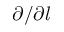Convert formula to latex. <formula><loc_0><loc_0><loc_500><loc_500>\partial / \partial l</formula> 